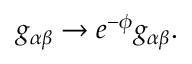Convert formula to latex. <formula><loc_0><loc_0><loc_500><loc_500>g _ { \alpha \beta } \rightarrow e ^ { - \phi } g _ { \alpha \beta } .</formula> 